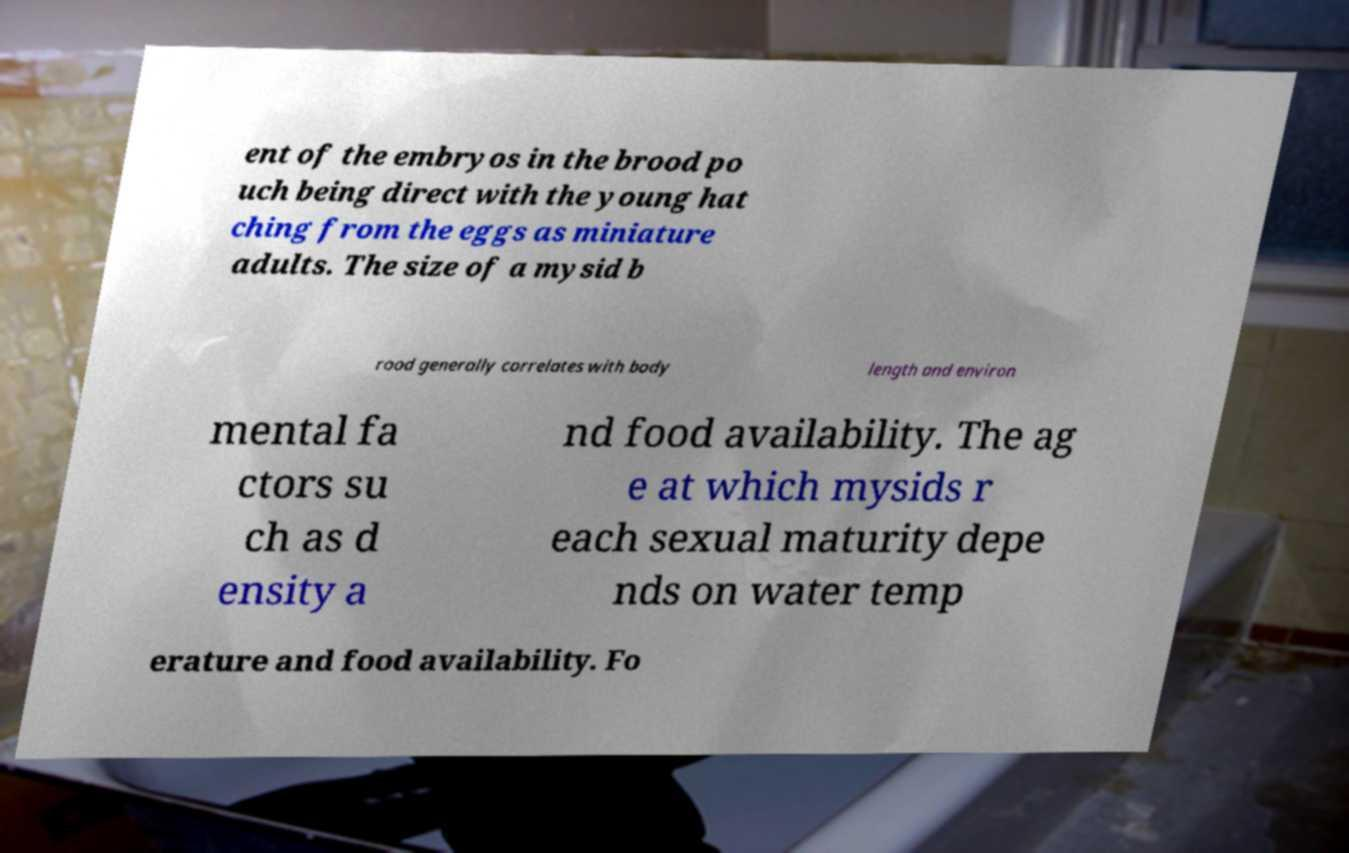There's text embedded in this image that I need extracted. Can you transcribe it verbatim? ent of the embryos in the brood po uch being direct with the young hat ching from the eggs as miniature adults. The size of a mysid b rood generally correlates with body length and environ mental fa ctors su ch as d ensity a nd food availability. The ag e at which mysids r each sexual maturity depe nds on water temp erature and food availability. Fo 